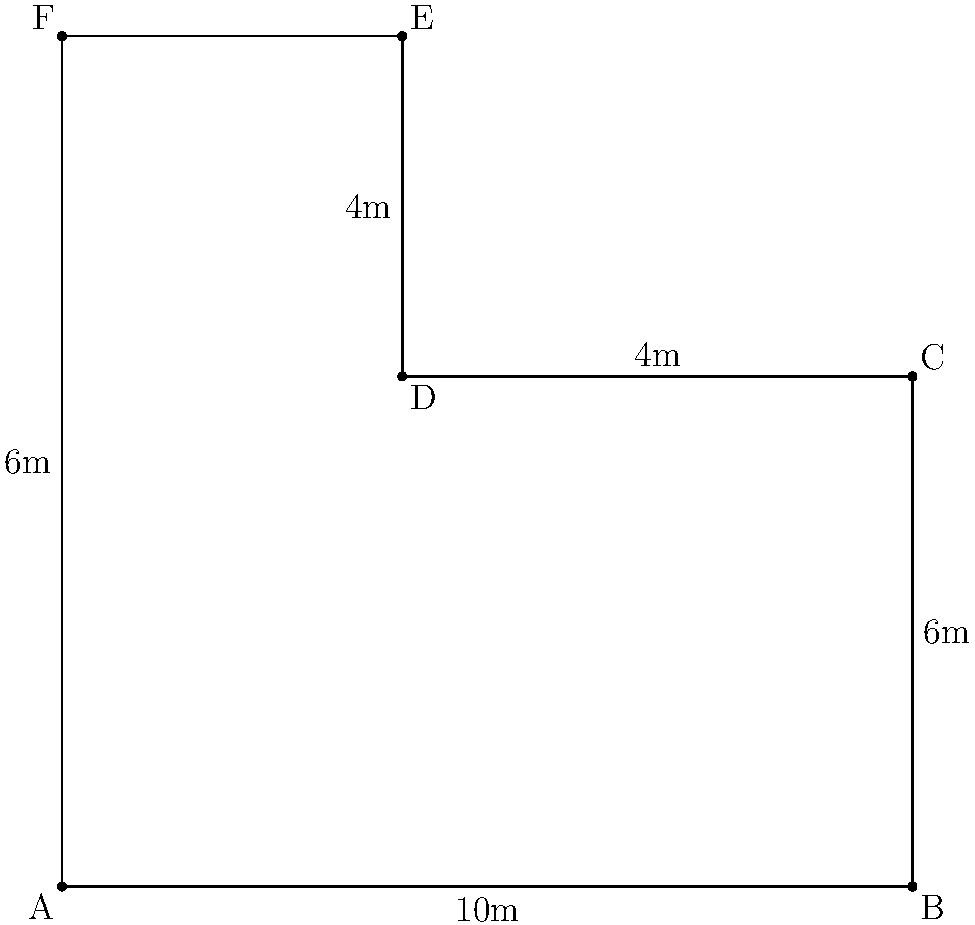As part of your luxury hotel expansion, you're designing an L-shaped pool deck for a new property. The deck's dimensions are shown in the diagram above. Calculate the perimeter of this pool deck to determine the length of decorative lighting needed to outline its edge. To find the perimeter of the L-shaped pool deck, we need to add up the lengths of all its sides:

1. Start at point A and move clockwise:
   AB = 10m
   BC = 6m
   CD = 6m (10m - 4m)
   DE = 4m
   EF = 4m
   FA = 6m

2. Add all these lengths:
   $$\text{Perimeter} = AB + BC + CD + DE + EF + FA$$
   $$\text{Perimeter} = 10m + 6m + 6m + 4m + 4m + 6m$$

3. Calculate the sum:
   $$\text{Perimeter} = 36m$$

Therefore, the perimeter of the L-shaped pool deck is 36 meters.
Answer: 36m 